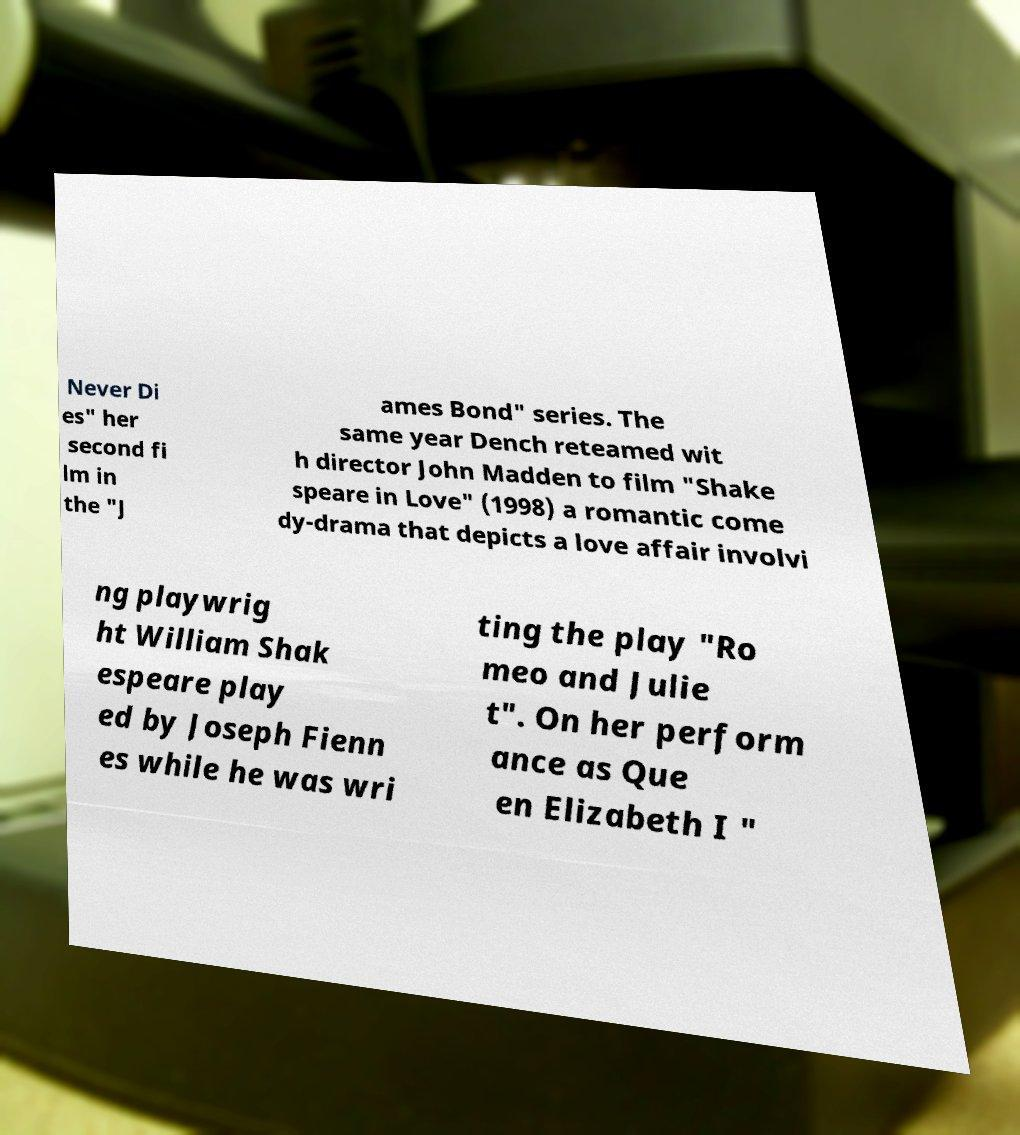For documentation purposes, I need the text within this image transcribed. Could you provide that? Never Di es" her second fi lm in the "J ames Bond" series. The same year Dench reteamed wit h director John Madden to film "Shake speare in Love" (1998) a romantic come dy-drama that depicts a love affair involvi ng playwrig ht William Shak espeare play ed by Joseph Fienn es while he was wri ting the play "Ro meo and Julie t". On her perform ance as Que en Elizabeth I " 